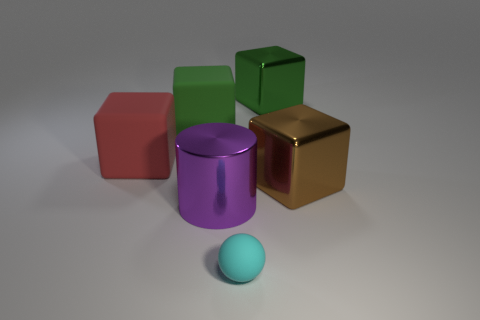Subtract all green cubes. Subtract all gray cylinders. How many cubes are left? 2 Add 2 green rubber things. How many objects exist? 8 Subtract all cylinders. How many objects are left? 5 Add 4 cyan matte things. How many cyan matte things exist? 5 Subtract 0 blue balls. How many objects are left? 6 Subtract all shiny cylinders. Subtract all purple spheres. How many objects are left? 5 Add 3 large matte things. How many large matte things are left? 5 